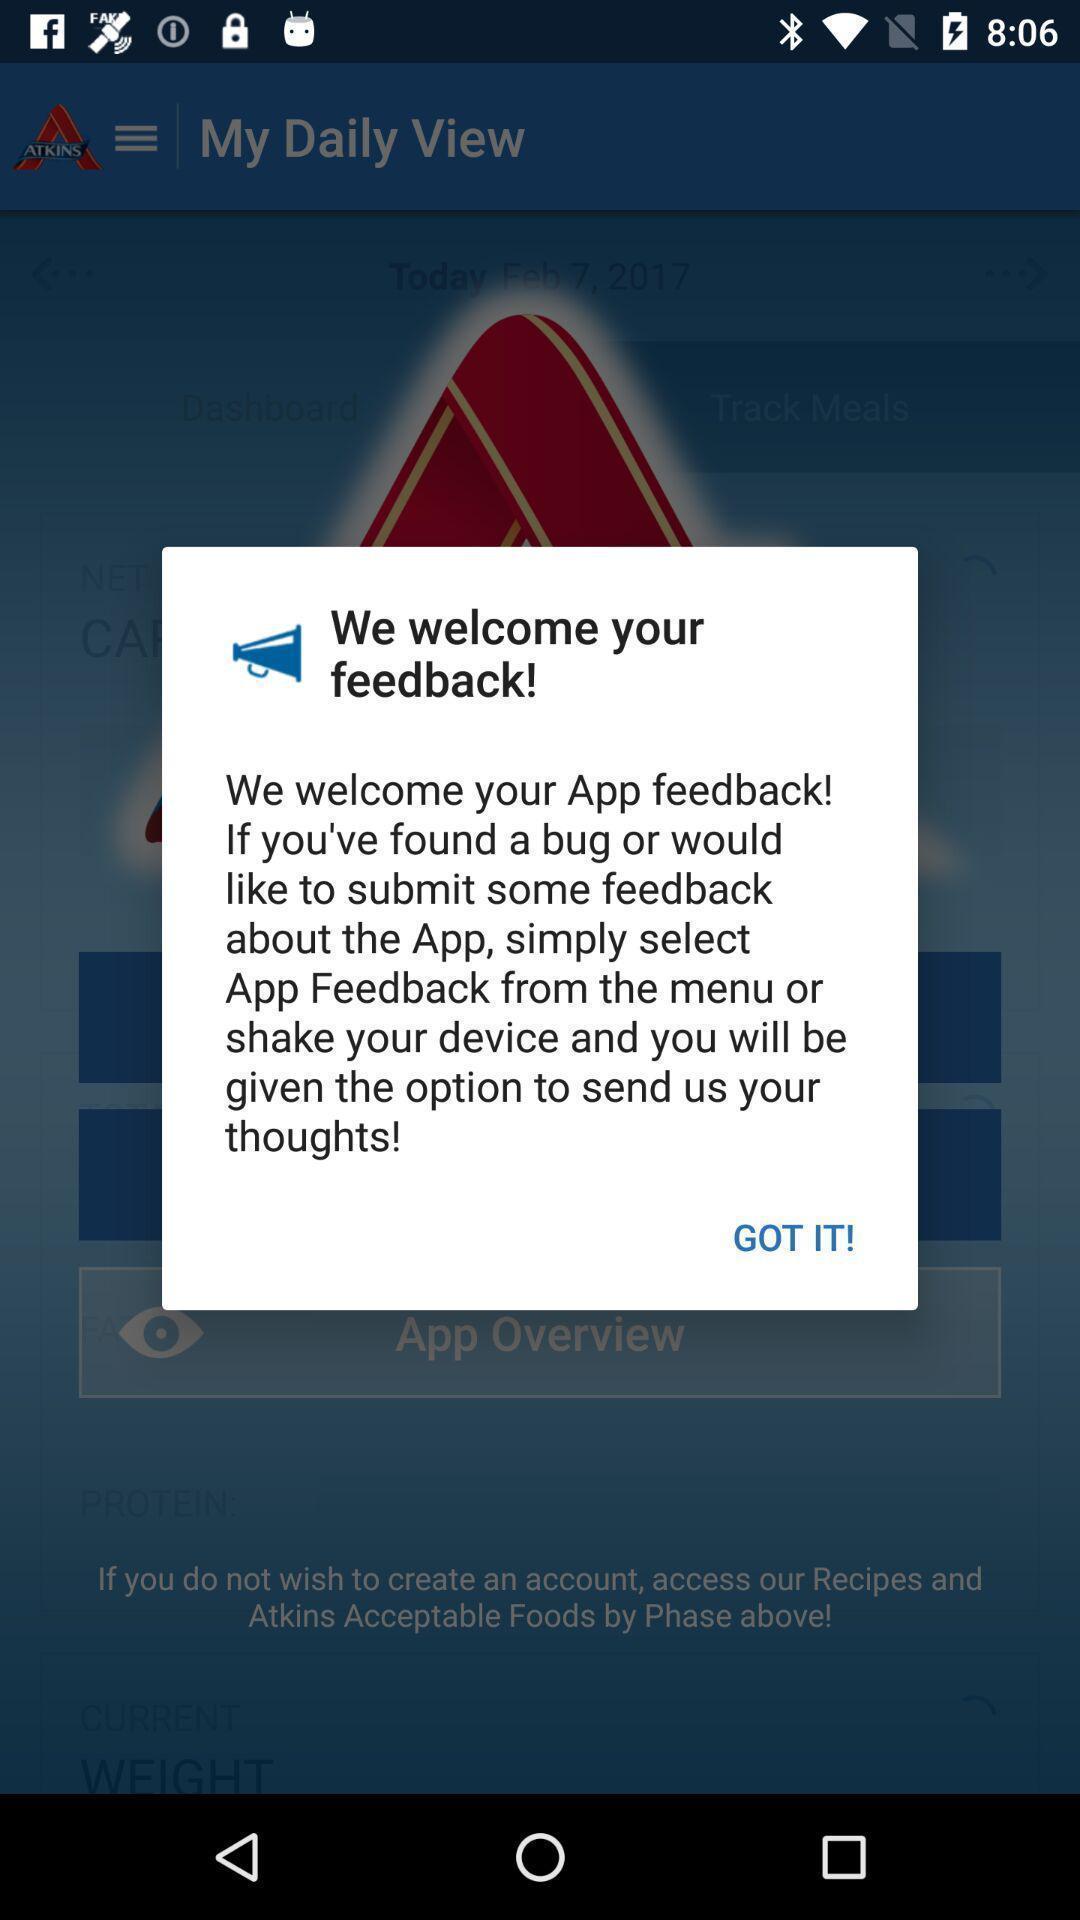Summarize the main components in this picture. Pop-up with options in a calorie tracking app. 